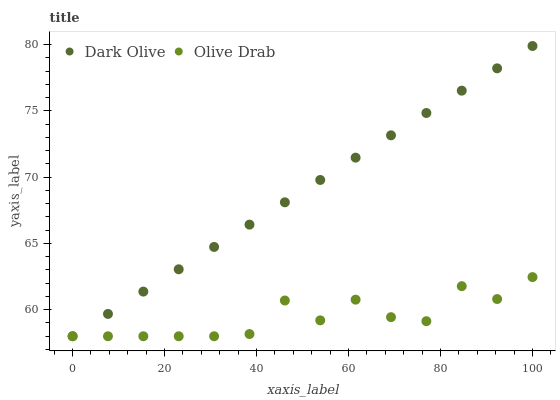Does Olive Drab have the minimum area under the curve?
Answer yes or no. Yes. Does Dark Olive have the maximum area under the curve?
Answer yes or no. Yes. Does Olive Drab have the maximum area under the curve?
Answer yes or no. No. Is Dark Olive the smoothest?
Answer yes or no. Yes. Is Olive Drab the roughest?
Answer yes or no. Yes. Is Olive Drab the smoothest?
Answer yes or no. No. Does Dark Olive have the lowest value?
Answer yes or no. Yes. Does Dark Olive have the highest value?
Answer yes or no. Yes. Does Olive Drab have the highest value?
Answer yes or no. No. Does Olive Drab intersect Dark Olive?
Answer yes or no. Yes. Is Olive Drab less than Dark Olive?
Answer yes or no. No. Is Olive Drab greater than Dark Olive?
Answer yes or no. No. 